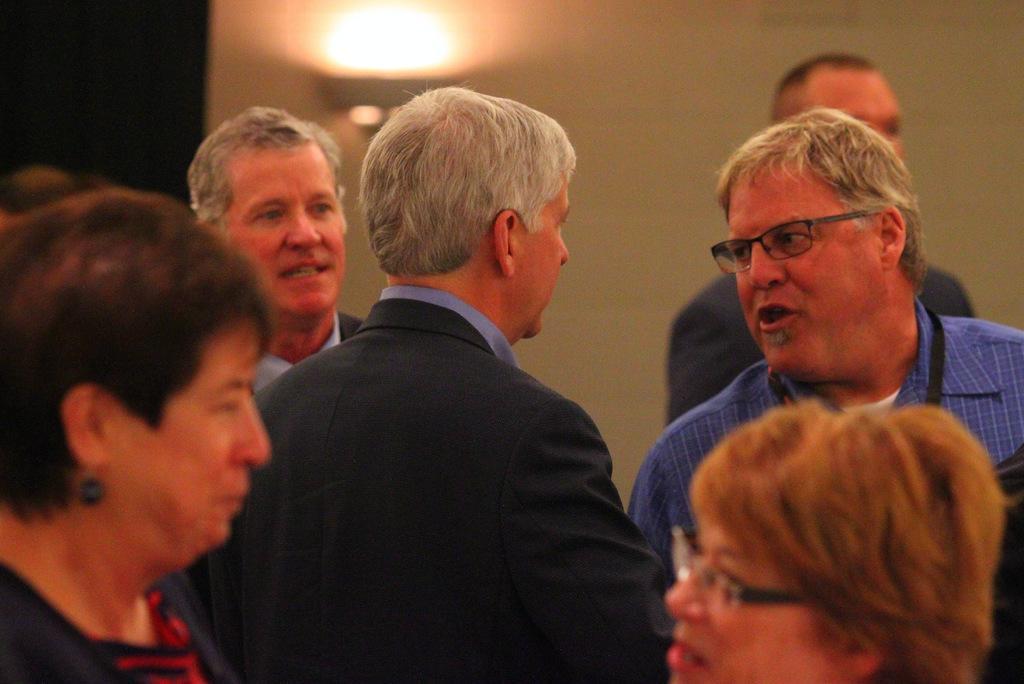How would you summarize this image in a sentence or two? In this image there are group of people standing, and in the background there is a light to the wall. 